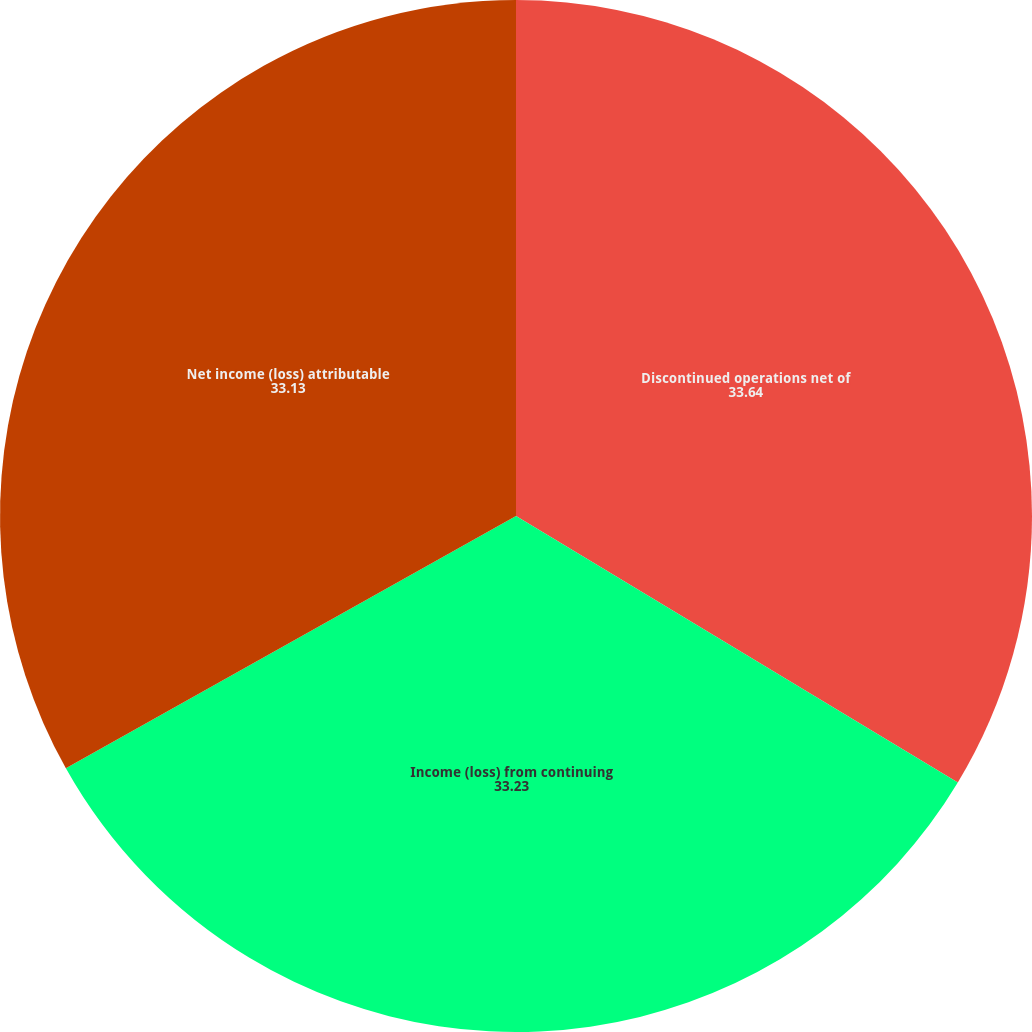<chart> <loc_0><loc_0><loc_500><loc_500><pie_chart><fcel>Discontinued operations net of<fcel>Income (loss) from continuing<fcel>Net income (loss) attributable<nl><fcel>33.64%<fcel>33.23%<fcel>33.13%<nl></chart> 